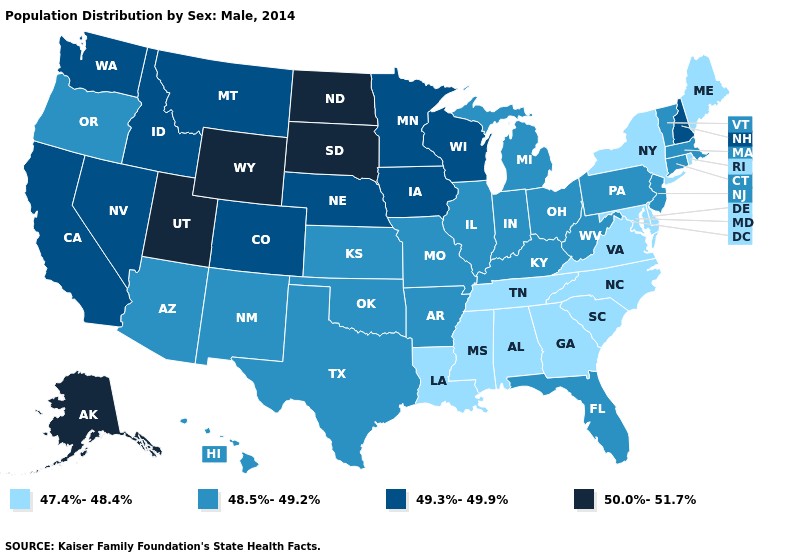Name the states that have a value in the range 50.0%-51.7%?
Give a very brief answer. Alaska, North Dakota, South Dakota, Utah, Wyoming. What is the value of Indiana?
Keep it brief. 48.5%-49.2%. Does California have the same value as Montana?
Answer briefly. Yes. Does North Dakota have the highest value in the USA?
Keep it brief. Yes. Which states have the highest value in the USA?
Short answer required. Alaska, North Dakota, South Dakota, Utah, Wyoming. Which states hav the highest value in the MidWest?
Be succinct. North Dakota, South Dakota. What is the lowest value in states that border Kentucky?
Answer briefly. 47.4%-48.4%. Is the legend a continuous bar?
Be succinct. No. Name the states that have a value in the range 49.3%-49.9%?
Concise answer only. California, Colorado, Idaho, Iowa, Minnesota, Montana, Nebraska, Nevada, New Hampshire, Washington, Wisconsin. Which states have the lowest value in the USA?
Write a very short answer. Alabama, Delaware, Georgia, Louisiana, Maine, Maryland, Mississippi, New York, North Carolina, Rhode Island, South Carolina, Tennessee, Virginia. Which states have the lowest value in the USA?
Answer briefly. Alabama, Delaware, Georgia, Louisiana, Maine, Maryland, Mississippi, New York, North Carolina, Rhode Island, South Carolina, Tennessee, Virginia. What is the lowest value in states that border California?
Be succinct. 48.5%-49.2%. Which states have the lowest value in the MidWest?
Keep it brief. Illinois, Indiana, Kansas, Michigan, Missouri, Ohio. What is the highest value in the USA?
Answer briefly. 50.0%-51.7%. Name the states that have a value in the range 50.0%-51.7%?
Short answer required. Alaska, North Dakota, South Dakota, Utah, Wyoming. 